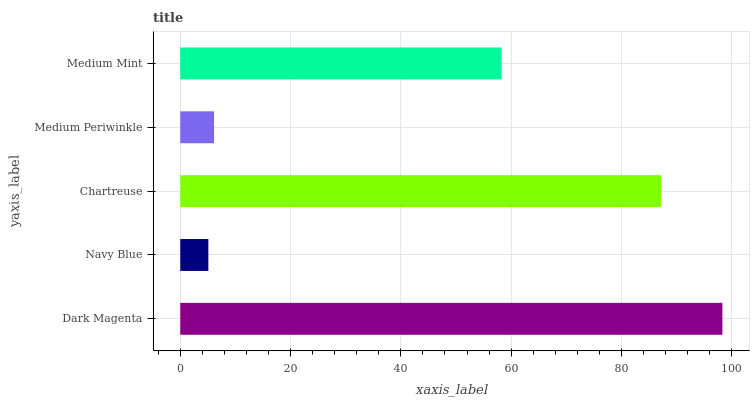Is Navy Blue the minimum?
Answer yes or no. Yes. Is Dark Magenta the maximum?
Answer yes or no. Yes. Is Chartreuse the minimum?
Answer yes or no. No. Is Chartreuse the maximum?
Answer yes or no. No. Is Chartreuse greater than Navy Blue?
Answer yes or no. Yes. Is Navy Blue less than Chartreuse?
Answer yes or no. Yes. Is Navy Blue greater than Chartreuse?
Answer yes or no. No. Is Chartreuse less than Navy Blue?
Answer yes or no. No. Is Medium Mint the high median?
Answer yes or no. Yes. Is Medium Mint the low median?
Answer yes or no. Yes. Is Navy Blue the high median?
Answer yes or no. No. Is Navy Blue the low median?
Answer yes or no. No. 